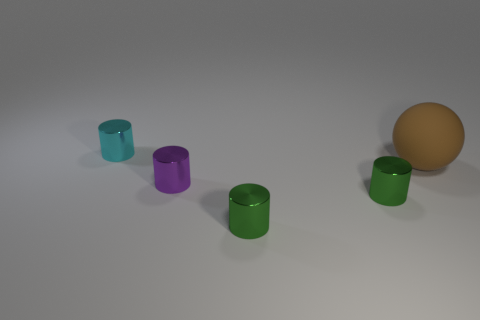Subtract all small purple shiny cylinders. How many cylinders are left? 3 Add 5 big green cubes. How many objects exist? 10 Subtract all green cylinders. How many cylinders are left? 2 Subtract 1 purple cylinders. How many objects are left? 4 Subtract all spheres. How many objects are left? 4 Subtract 1 balls. How many balls are left? 0 Subtract all purple cylinders. Subtract all red cubes. How many cylinders are left? 3 Subtract all brown spheres. How many green cylinders are left? 2 Subtract all small gray rubber balls. Subtract all big brown spheres. How many objects are left? 4 Add 2 green things. How many green things are left? 4 